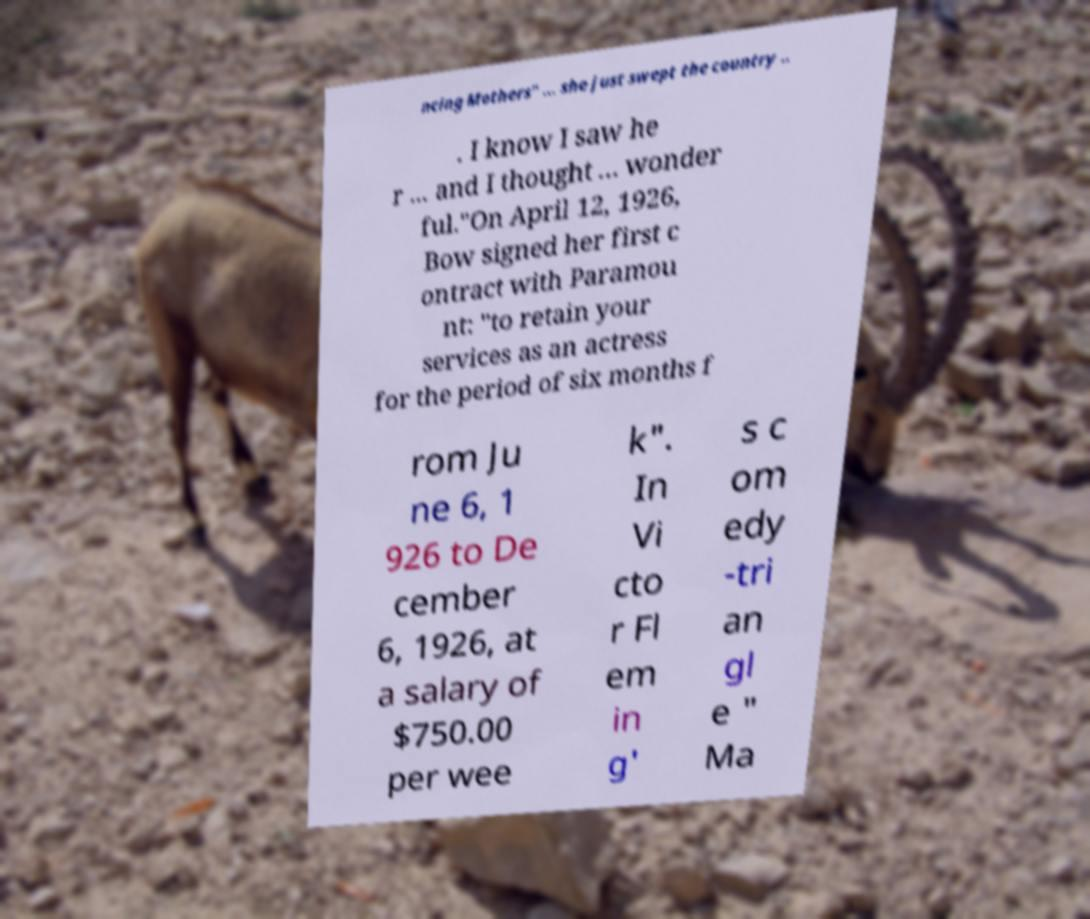Please read and relay the text visible in this image. What does it say? ncing Mothers" ... she just swept the country .. . I know I saw he r ... and I thought ... wonder ful."On April 12, 1926, Bow signed her first c ontract with Paramou nt: "to retain your services as an actress for the period of six months f rom Ju ne 6, 1 926 to De cember 6, 1926, at a salary of $750.00 per wee k". In Vi cto r Fl em in g' s c om edy -tri an gl e " Ma 